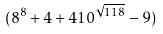Convert formula to latex. <formula><loc_0><loc_0><loc_500><loc_500>( 8 ^ { 8 } + 4 + 4 1 0 ^ { \sqrt { 1 1 8 } } - 9 )</formula> 